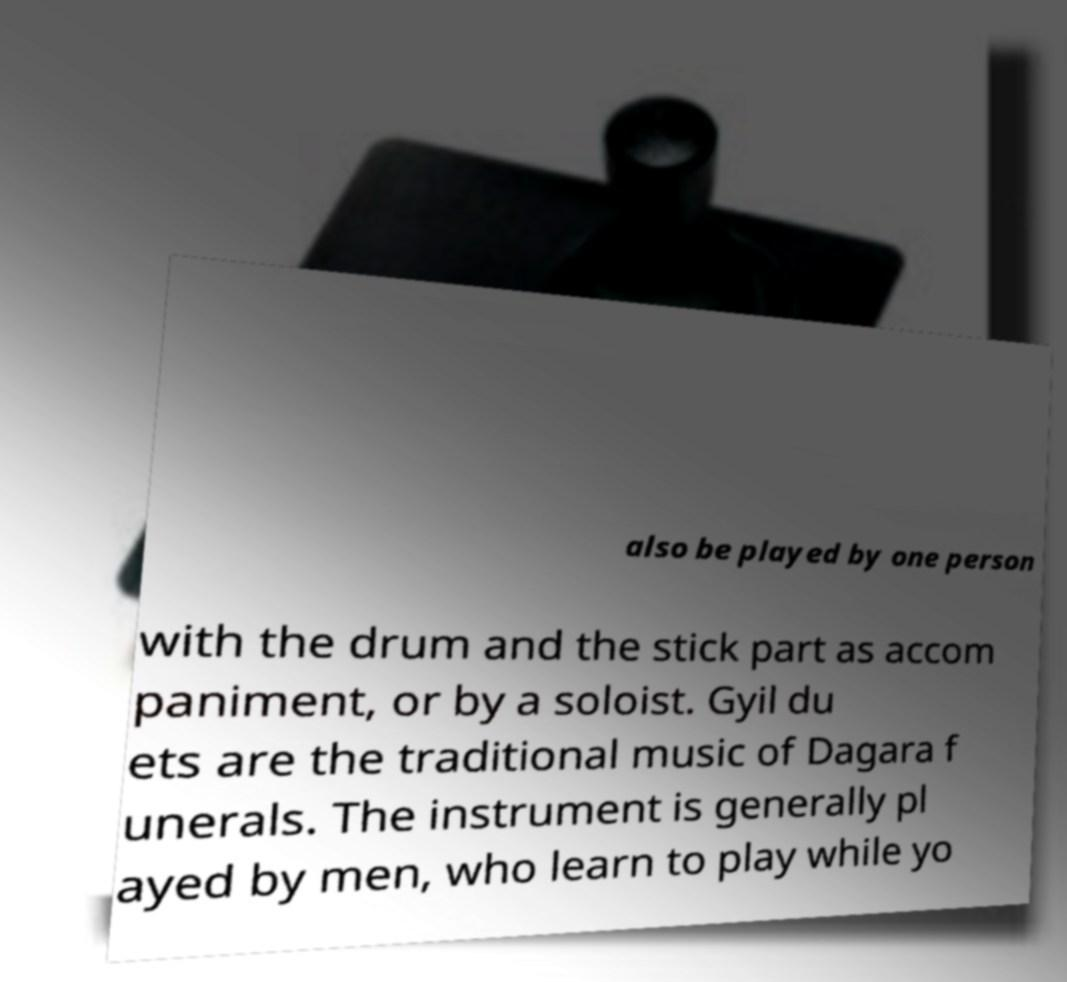There's text embedded in this image that I need extracted. Can you transcribe it verbatim? also be played by one person with the drum and the stick part as accom paniment, or by a soloist. Gyil du ets are the traditional music of Dagara f unerals. The instrument is generally pl ayed by men, who learn to play while yo 